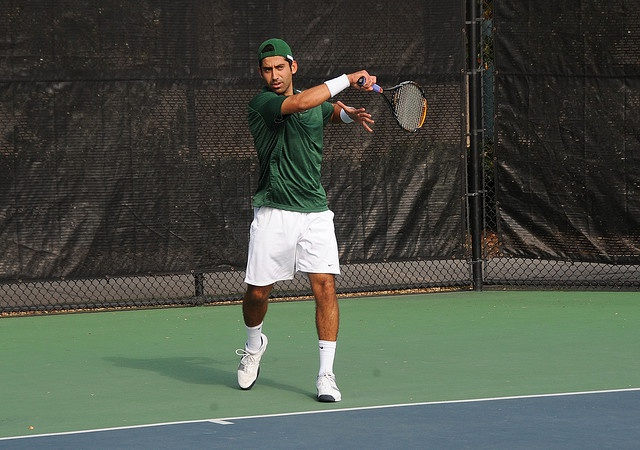Describe the objects in this image and their specific colors. I can see people in black, white, teal, and darkgreen tones and tennis racket in black, gray, and darkgray tones in this image. 